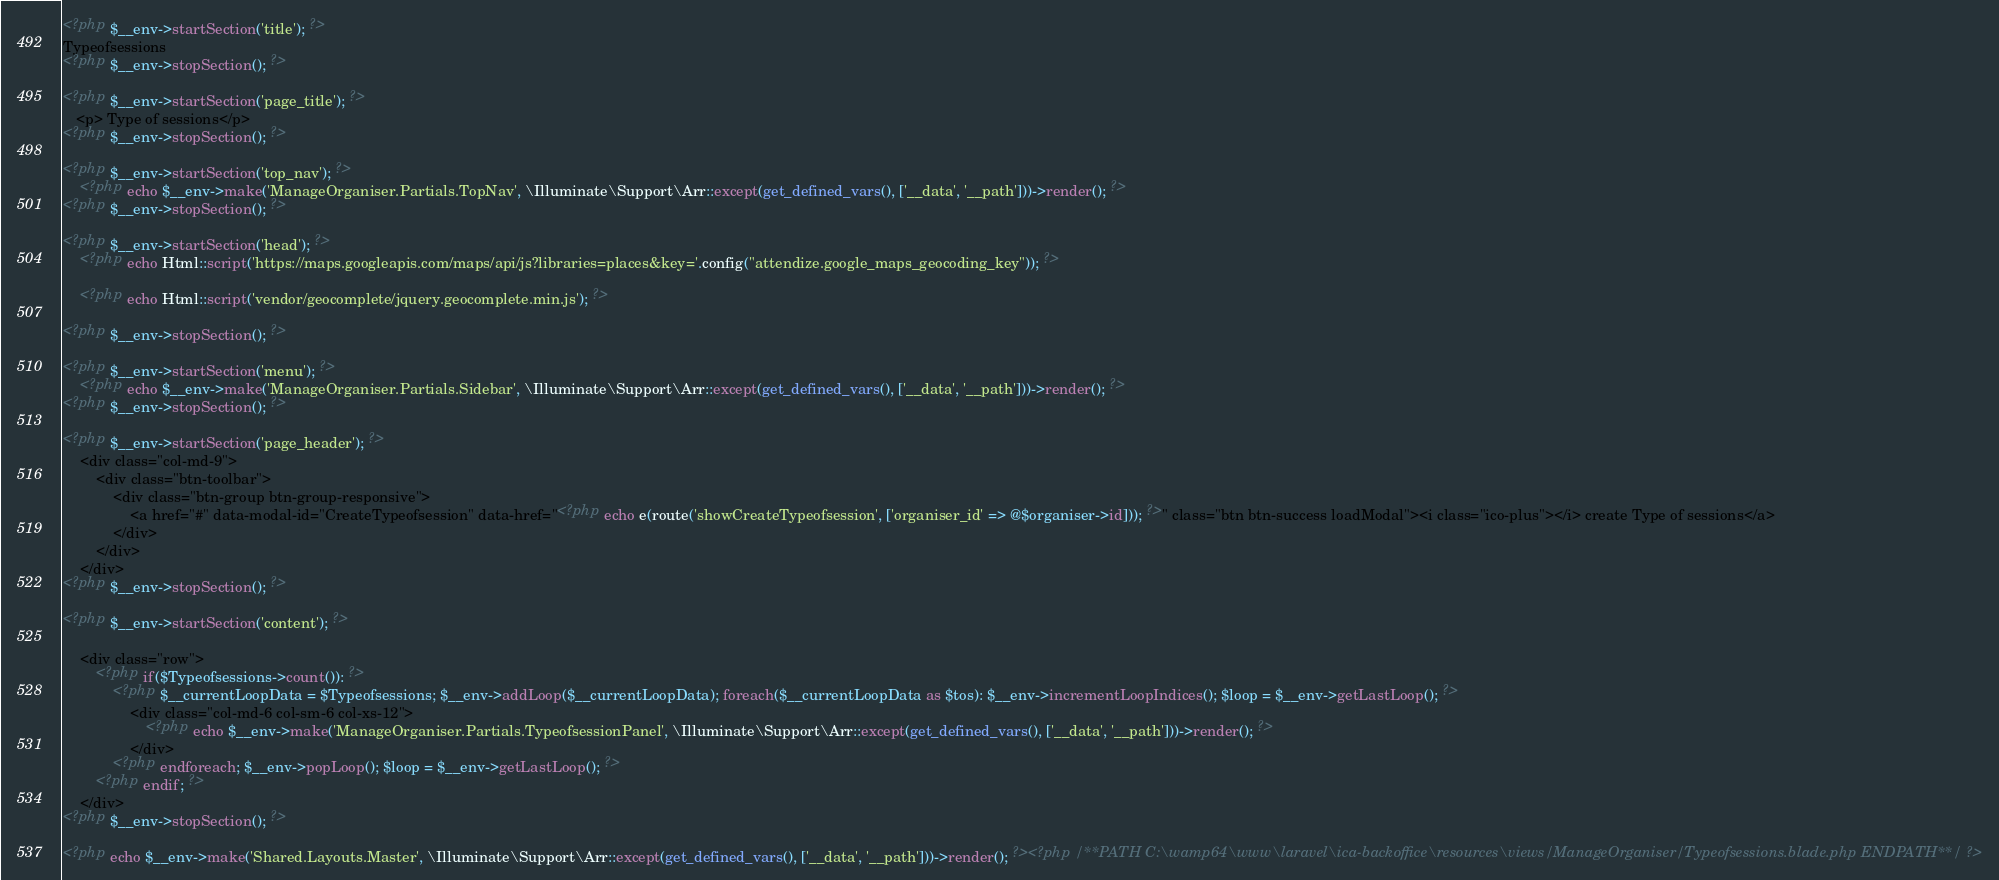Convert code to text. <code><loc_0><loc_0><loc_500><loc_500><_PHP_><?php $__env->startSection('title'); ?>
Typeofsessions
<?php $__env->stopSection(); ?>

<?php $__env->startSection('page_title'); ?>
   <p> Type of sessions</p>
<?php $__env->stopSection(); ?>

<?php $__env->startSection('top_nav'); ?>
    <?php echo $__env->make('ManageOrganiser.Partials.TopNav', \Illuminate\Support\Arr::except(get_defined_vars(), ['__data', '__path']))->render(); ?>
<?php $__env->stopSection(); ?>

<?php $__env->startSection('head'); ?>
    <?php echo Html::script('https://maps.googleapis.com/maps/api/js?libraries=places&key='.config("attendize.google_maps_geocoding_key")); ?>

    <?php echo Html::script('vendor/geocomplete/jquery.geocomplete.min.js'); ?>

<?php $__env->stopSection(); ?>

<?php $__env->startSection('menu'); ?>
    <?php echo $__env->make('ManageOrganiser.Partials.Sidebar', \Illuminate\Support\Arr::except(get_defined_vars(), ['__data', '__path']))->render(); ?>
<?php $__env->stopSection(); ?>

<?php $__env->startSection('page_header'); ?>
    <div class="col-md-9">
        <div class="btn-toolbar">
            <div class="btn-group btn-group-responsive">
                <a href="#" data-modal-id="CreateTypeofsession" data-href="<?php echo e(route('showCreateTypeofsession', ['organiser_id' => @$organiser->id])); ?>" class="btn btn-success loadModal"><i class="ico-plus"></i> create Type of sessions</a>
            </div>
        </div>
    </div>
<?php $__env->stopSection(); ?>

<?php $__env->startSection('content'); ?>

    <div class="row">
        <?php if($Typeofsessions->count()): ?>
            <?php $__currentLoopData = $Typeofsessions; $__env->addLoop($__currentLoopData); foreach($__currentLoopData as $tos): $__env->incrementLoopIndices(); $loop = $__env->getLastLoop(); ?>
                <div class="col-md-6 col-sm-6 col-xs-12">
                    <?php echo $__env->make('ManageOrganiser.Partials.TypeofsessionPanel', \Illuminate\Support\Arr::except(get_defined_vars(), ['__data', '__path']))->render(); ?>
                </div>
            <?php endforeach; $__env->popLoop(); $loop = $__env->getLastLoop(); ?>
        <?php endif; ?>
    </div>
<?php $__env->stopSection(); ?>

<?php echo $__env->make('Shared.Layouts.Master', \Illuminate\Support\Arr::except(get_defined_vars(), ['__data', '__path']))->render(); ?><?php /**PATH C:\wamp64\www\laravel\ica-backoffice\resources\views/ManageOrganiser/Typeofsessions.blade.php ENDPATH**/ ?></code> 